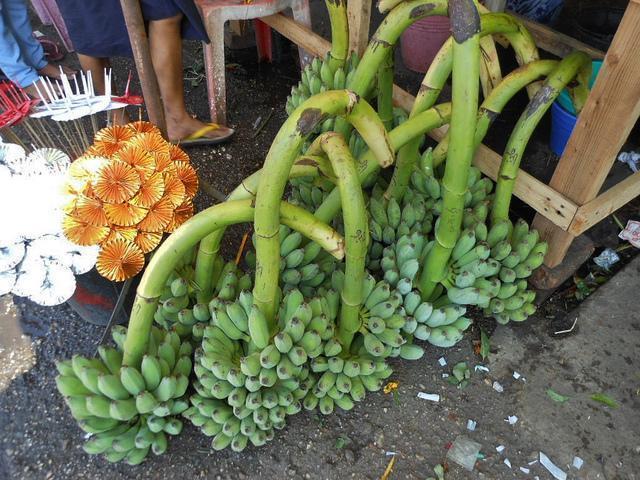What is the brown post behind the green fruit made of?
From the following four choices, select the correct answer to address the question.
Options: Sand, concrete, wood, plastic. Wood. 